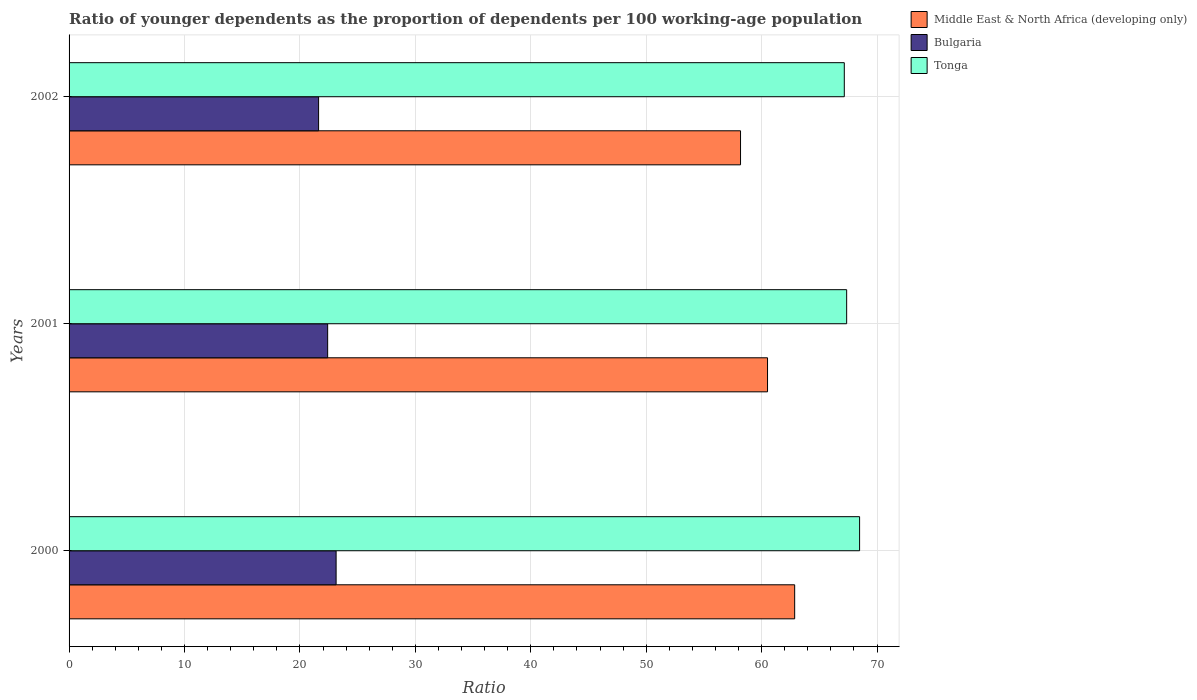How many different coloured bars are there?
Ensure brevity in your answer.  3. How many groups of bars are there?
Offer a terse response. 3. Are the number of bars per tick equal to the number of legend labels?
Give a very brief answer. Yes. Are the number of bars on each tick of the Y-axis equal?
Offer a terse response. Yes. How many bars are there on the 1st tick from the top?
Provide a short and direct response. 3. How many bars are there on the 3rd tick from the bottom?
Your answer should be compact. 3. What is the label of the 1st group of bars from the top?
Give a very brief answer. 2002. What is the age dependency ratio(young) in Tonga in 2002?
Make the answer very short. 67.17. Across all years, what is the maximum age dependency ratio(young) in Middle East & North Africa (developing only)?
Your response must be concise. 62.87. Across all years, what is the minimum age dependency ratio(young) in Tonga?
Provide a succinct answer. 67.17. In which year was the age dependency ratio(young) in Middle East & North Africa (developing only) minimum?
Provide a short and direct response. 2002. What is the total age dependency ratio(young) in Tonga in the graph?
Offer a terse response. 203.03. What is the difference between the age dependency ratio(young) in Bulgaria in 2000 and that in 2002?
Keep it short and to the point. 1.52. What is the difference between the age dependency ratio(young) in Bulgaria in 2000 and the age dependency ratio(young) in Middle East & North Africa (developing only) in 2001?
Offer a very short reply. -37.38. What is the average age dependency ratio(young) in Middle East & North Africa (developing only) per year?
Keep it short and to the point. 60.52. In the year 2002, what is the difference between the age dependency ratio(young) in Bulgaria and age dependency ratio(young) in Tonga?
Offer a terse response. -45.55. In how many years, is the age dependency ratio(young) in Bulgaria greater than 14 ?
Ensure brevity in your answer.  3. What is the ratio of the age dependency ratio(young) in Middle East & North Africa (developing only) in 2001 to that in 2002?
Your answer should be compact. 1.04. Is the age dependency ratio(young) in Tonga in 2000 less than that in 2001?
Offer a very short reply. No. What is the difference between the highest and the second highest age dependency ratio(young) in Tonga?
Keep it short and to the point. 1.12. What is the difference between the highest and the lowest age dependency ratio(young) in Tonga?
Your answer should be very brief. 1.33. In how many years, is the age dependency ratio(young) in Tonga greater than the average age dependency ratio(young) in Tonga taken over all years?
Your response must be concise. 1. Is the sum of the age dependency ratio(young) in Bulgaria in 2001 and 2002 greater than the maximum age dependency ratio(young) in Tonga across all years?
Ensure brevity in your answer.  No. What does the 1st bar from the bottom in 2000 represents?
Offer a very short reply. Middle East & North Africa (developing only). Is it the case that in every year, the sum of the age dependency ratio(young) in Bulgaria and age dependency ratio(young) in Middle East & North Africa (developing only) is greater than the age dependency ratio(young) in Tonga?
Offer a very short reply. Yes. How many years are there in the graph?
Your answer should be very brief. 3. What is the difference between two consecutive major ticks on the X-axis?
Your answer should be compact. 10. How many legend labels are there?
Your answer should be very brief. 3. How are the legend labels stacked?
Make the answer very short. Vertical. What is the title of the graph?
Make the answer very short. Ratio of younger dependents as the proportion of dependents per 100 working-age population. What is the label or title of the X-axis?
Keep it short and to the point. Ratio. What is the Ratio in Middle East & North Africa (developing only) in 2000?
Make the answer very short. 62.87. What is the Ratio in Bulgaria in 2000?
Ensure brevity in your answer.  23.14. What is the Ratio in Tonga in 2000?
Give a very brief answer. 68.49. What is the Ratio in Middle East & North Africa (developing only) in 2001?
Make the answer very short. 60.51. What is the Ratio of Bulgaria in 2001?
Provide a succinct answer. 22.4. What is the Ratio in Tonga in 2001?
Make the answer very short. 67.37. What is the Ratio in Middle East & North Africa (developing only) in 2002?
Your answer should be compact. 58.18. What is the Ratio in Bulgaria in 2002?
Make the answer very short. 21.62. What is the Ratio of Tonga in 2002?
Your answer should be very brief. 67.17. Across all years, what is the maximum Ratio in Middle East & North Africa (developing only)?
Offer a very short reply. 62.87. Across all years, what is the maximum Ratio in Bulgaria?
Your answer should be compact. 23.14. Across all years, what is the maximum Ratio in Tonga?
Keep it short and to the point. 68.49. Across all years, what is the minimum Ratio in Middle East & North Africa (developing only)?
Your answer should be very brief. 58.18. Across all years, what is the minimum Ratio in Bulgaria?
Offer a terse response. 21.62. Across all years, what is the minimum Ratio of Tonga?
Make the answer very short. 67.17. What is the total Ratio in Middle East & North Africa (developing only) in the graph?
Make the answer very short. 181.56. What is the total Ratio of Bulgaria in the graph?
Keep it short and to the point. 67.16. What is the total Ratio in Tonga in the graph?
Provide a short and direct response. 203.03. What is the difference between the Ratio in Middle East & North Africa (developing only) in 2000 and that in 2001?
Provide a short and direct response. 2.35. What is the difference between the Ratio in Bulgaria in 2000 and that in 2001?
Give a very brief answer. 0.73. What is the difference between the Ratio of Tonga in 2000 and that in 2001?
Ensure brevity in your answer.  1.12. What is the difference between the Ratio of Middle East & North Africa (developing only) in 2000 and that in 2002?
Your answer should be compact. 4.69. What is the difference between the Ratio in Bulgaria in 2000 and that in 2002?
Provide a short and direct response. 1.52. What is the difference between the Ratio of Tonga in 2000 and that in 2002?
Make the answer very short. 1.33. What is the difference between the Ratio of Middle East & North Africa (developing only) in 2001 and that in 2002?
Your response must be concise. 2.34. What is the difference between the Ratio in Bulgaria in 2001 and that in 2002?
Provide a succinct answer. 0.78. What is the difference between the Ratio of Tonga in 2001 and that in 2002?
Offer a terse response. 0.2. What is the difference between the Ratio in Middle East & North Africa (developing only) in 2000 and the Ratio in Bulgaria in 2001?
Keep it short and to the point. 40.46. What is the difference between the Ratio in Middle East & North Africa (developing only) in 2000 and the Ratio in Tonga in 2001?
Your answer should be very brief. -4.5. What is the difference between the Ratio of Bulgaria in 2000 and the Ratio of Tonga in 2001?
Make the answer very short. -44.23. What is the difference between the Ratio in Middle East & North Africa (developing only) in 2000 and the Ratio in Bulgaria in 2002?
Your answer should be compact. 41.25. What is the difference between the Ratio in Middle East & North Africa (developing only) in 2000 and the Ratio in Tonga in 2002?
Give a very brief answer. -4.3. What is the difference between the Ratio of Bulgaria in 2000 and the Ratio of Tonga in 2002?
Your answer should be compact. -44.03. What is the difference between the Ratio in Middle East & North Africa (developing only) in 2001 and the Ratio in Bulgaria in 2002?
Ensure brevity in your answer.  38.9. What is the difference between the Ratio in Middle East & North Africa (developing only) in 2001 and the Ratio in Tonga in 2002?
Your answer should be compact. -6.65. What is the difference between the Ratio in Bulgaria in 2001 and the Ratio in Tonga in 2002?
Provide a short and direct response. -44.76. What is the average Ratio of Middle East & North Africa (developing only) per year?
Give a very brief answer. 60.52. What is the average Ratio in Bulgaria per year?
Your answer should be compact. 22.39. What is the average Ratio of Tonga per year?
Ensure brevity in your answer.  67.68. In the year 2000, what is the difference between the Ratio of Middle East & North Africa (developing only) and Ratio of Bulgaria?
Make the answer very short. 39.73. In the year 2000, what is the difference between the Ratio in Middle East & North Africa (developing only) and Ratio in Tonga?
Ensure brevity in your answer.  -5.62. In the year 2000, what is the difference between the Ratio in Bulgaria and Ratio in Tonga?
Your answer should be very brief. -45.35. In the year 2001, what is the difference between the Ratio in Middle East & North Africa (developing only) and Ratio in Bulgaria?
Your response must be concise. 38.11. In the year 2001, what is the difference between the Ratio of Middle East & North Africa (developing only) and Ratio of Tonga?
Your answer should be very brief. -6.86. In the year 2001, what is the difference between the Ratio of Bulgaria and Ratio of Tonga?
Keep it short and to the point. -44.97. In the year 2002, what is the difference between the Ratio in Middle East & North Africa (developing only) and Ratio in Bulgaria?
Your answer should be very brief. 36.56. In the year 2002, what is the difference between the Ratio of Middle East & North Africa (developing only) and Ratio of Tonga?
Provide a short and direct response. -8.99. In the year 2002, what is the difference between the Ratio in Bulgaria and Ratio in Tonga?
Make the answer very short. -45.55. What is the ratio of the Ratio in Middle East & North Africa (developing only) in 2000 to that in 2001?
Provide a succinct answer. 1.04. What is the ratio of the Ratio of Bulgaria in 2000 to that in 2001?
Offer a terse response. 1.03. What is the ratio of the Ratio of Tonga in 2000 to that in 2001?
Provide a short and direct response. 1.02. What is the ratio of the Ratio of Middle East & North Africa (developing only) in 2000 to that in 2002?
Provide a succinct answer. 1.08. What is the ratio of the Ratio in Bulgaria in 2000 to that in 2002?
Keep it short and to the point. 1.07. What is the ratio of the Ratio of Tonga in 2000 to that in 2002?
Make the answer very short. 1.02. What is the ratio of the Ratio of Middle East & North Africa (developing only) in 2001 to that in 2002?
Offer a very short reply. 1.04. What is the ratio of the Ratio of Bulgaria in 2001 to that in 2002?
Ensure brevity in your answer.  1.04. What is the difference between the highest and the second highest Ratio of Middle East & North Africa (developing only)?
Your answer should be very brief. 2.35. What is the difference between the highest and the second highest Ratio of Bulgaria?
Your answer should be compact. 0.73. What is the difference between the highest and the second highest Ratio in Tonga?
Give a very brief answer. 1.12. What is the difference between the highest and the lowest Ratio of Middle East & North Africa (developing only)?
Offer a terse response. 4.69. What is the difference between the highest and the lowest Ratio in Bulgaria?
Make the answer very short. 1.52. What is the difference between the highest and the lowest Ratio in Tonga?
Your answer should be compact. 1.33. 